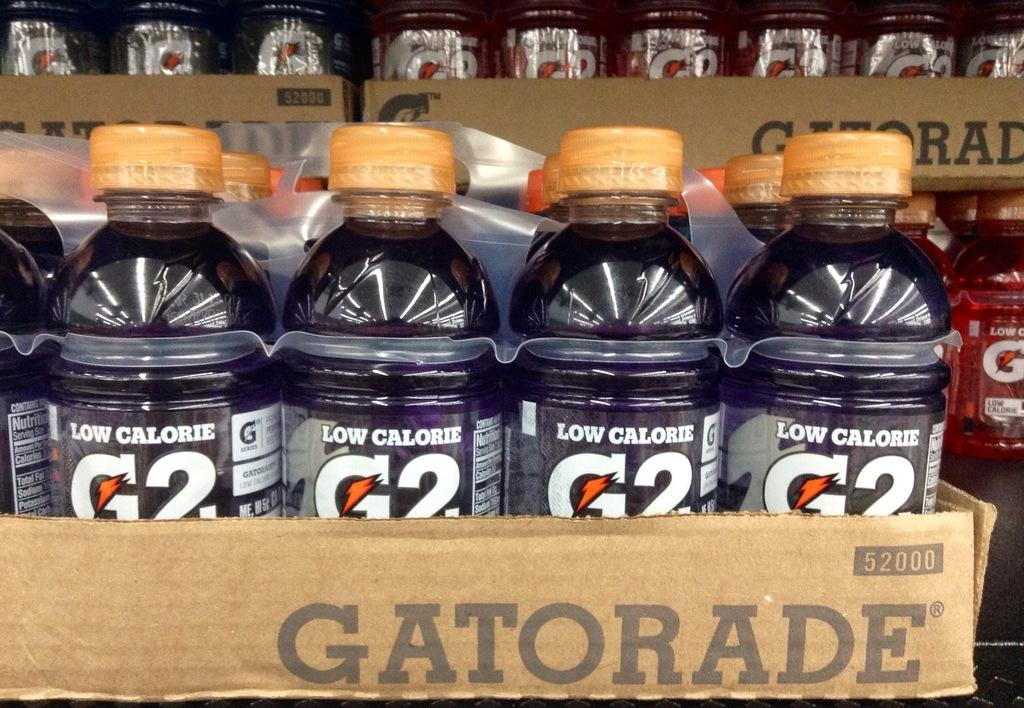<image>
Create a compact narrative representing the image presented. A case of purple Gatorade sits in front of a case of red gatorade 